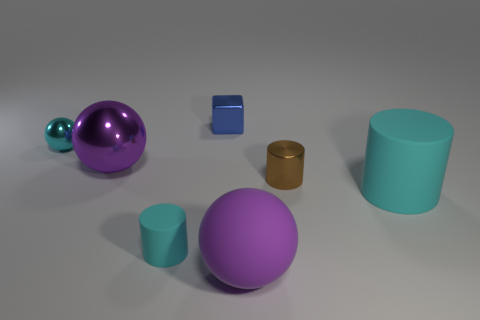Add 1 spheres. How many objects exist? 8 Subtract all balls. How many objects are left? 4 Subtract 0 cyan cubes. How many objects are left? 7 Subtract all large balls. Subtract all tiny rubber cylinders. How many objects are left? 4 Add 1 cyan matte things. How many cyan matte things are left? 3 Add 6 big cyan things. How many big cyan things exist? 7 